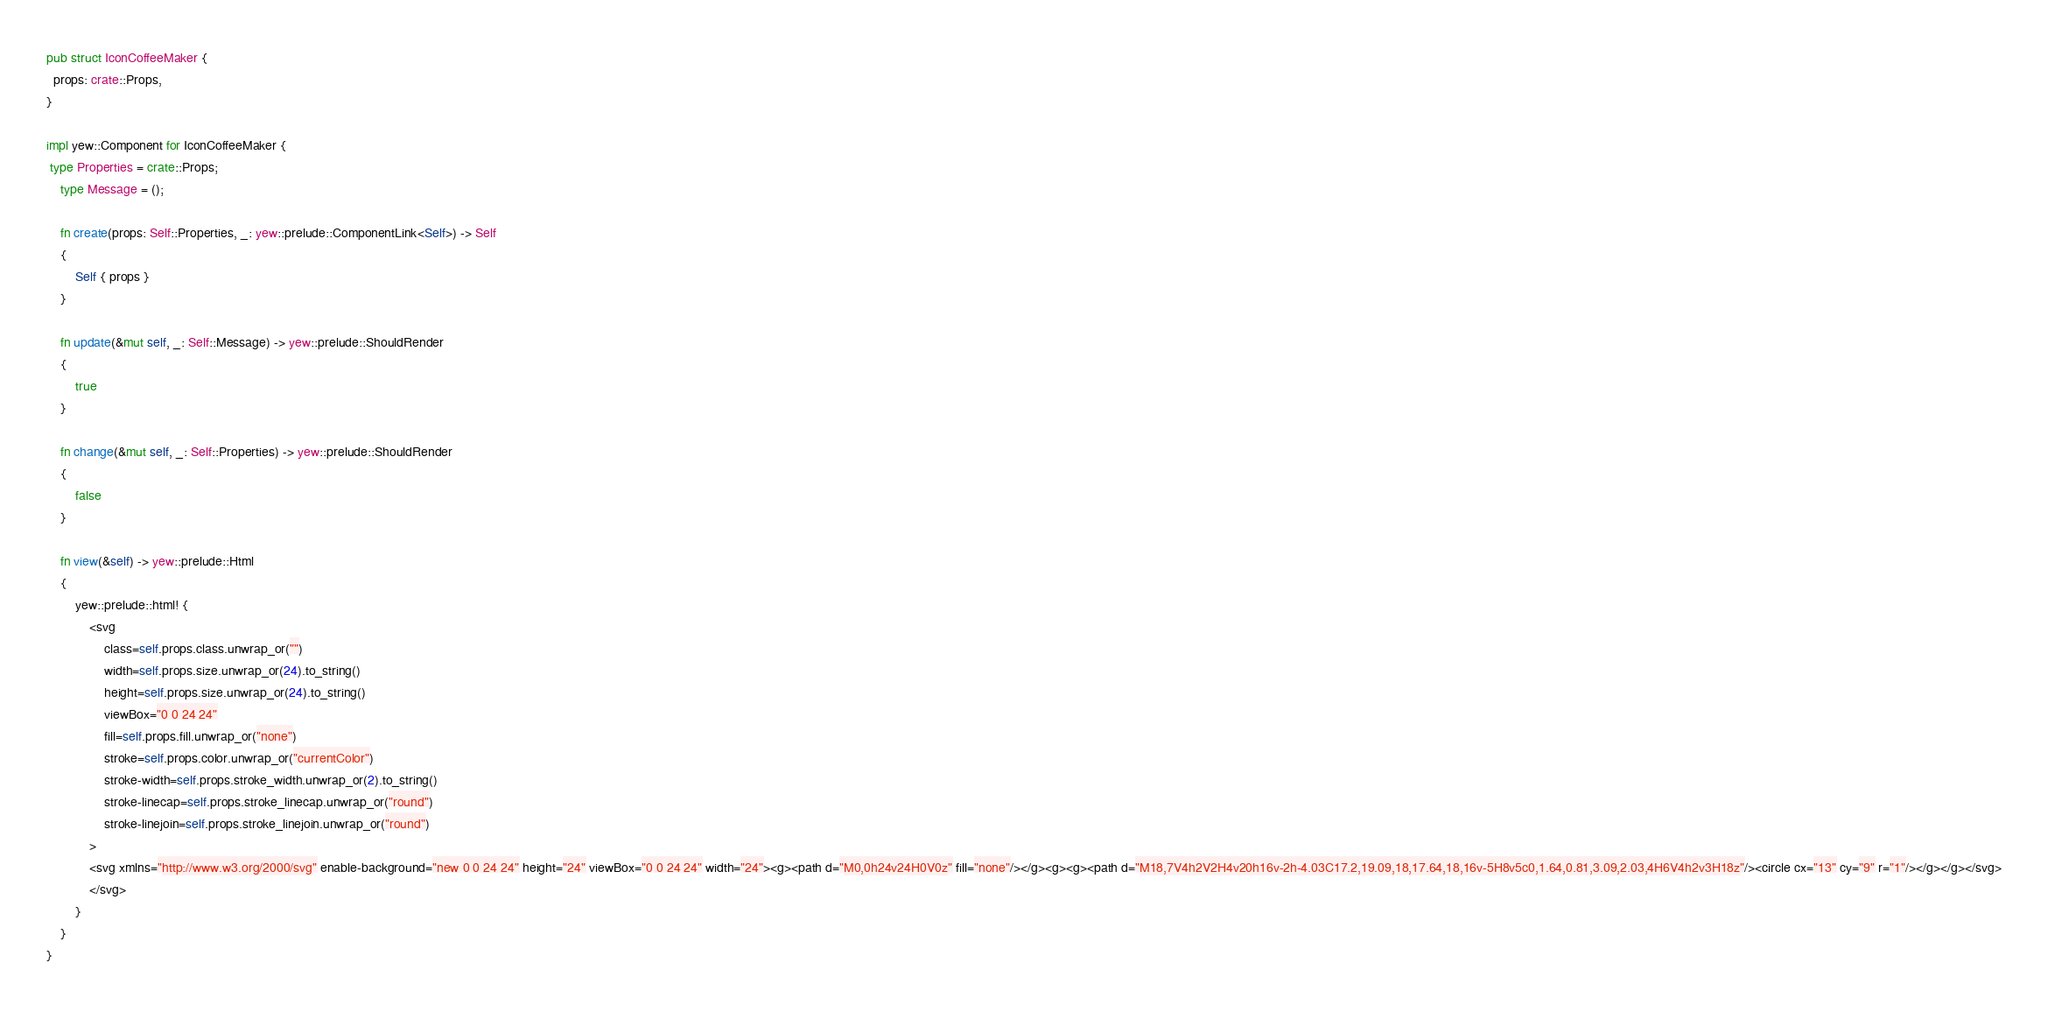Convert code to text. <code><loc_0><loc_0><loc_500><loc_500><_Rust_>
pub struct IconCoffeeMaker {
  props: crate::Props,
}

impl yew::Component for IconCoffeeMaker {
 type Properties = crate::Props;
    type Message = ();

    fn create(props: Self::Properties, _: yew::prelude::ComponentLink<Self>) -> Self
    {
        Self { props }
    }

    fn update(&mut self, _: Self::Message) -> yew::prelude::ShouldRender
    {
        true
    }

    fn change(&mut self, _: Self::Properties) -> yew::prelude::ShouldRender
    {
        false
    }

    fn view(&self) -> yew::prelude::Html
    {
        yew::prelude::html! {
            <svg
                class=self.props.class.unwrap_or("")
                width=self.props.size.unwrap_or(24).to_string()
                height=self.props.size.unwrap_or(24).to_string()
                viewBox="0 0 24 24"
                fill=self.props.fill.unwrap_or("none")
                stroke=self.props.color.unwrap_or("currentColor")
                stroke-width=self.props.stroke_width.unwrap_or(2).to_string()
                stroke-linecap=self.props.stroke_linecap.unwrap_or("round")
                stroke-linejoin=self.props.stroke_linejoin.unwrap_or("round")
            >
            <svg xmlns="http://www.w3.org/2000/svg" enable-background="new 0 0 24 24" height="24" viewBox="0 0 24 24" width="24"><g><path d="M0,0h24v24H0V0z" fill="none"/></g><g><g><path d="M18,7V4h2V2H4v20h16v-2h-4.03C17.2,19.09,18,17.64,18,16v-5H8v5c0,1.64,0.81,3.09,2.03,4H6V4h2v3H18z"/><circle cx="13" cy="9" r="1"/></g></g></svg>
            </svg>
        }
    }
}


</code> 